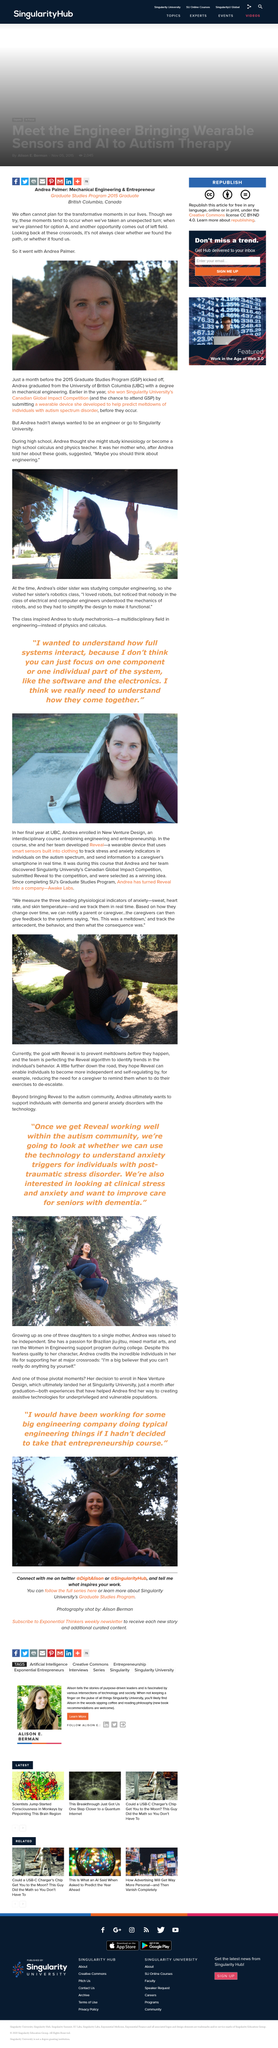Specify some key components in this picture. We, at Reveal, aspire to empower individuals by enabling them to become more independent and self-regulating. Andrea was raised to be independent, and as a result, she is self-reliant and confident in her abilities. The depiction of Andrea is present in the photo. Andrea graduated from the University of British Columbia just a month before the 2015 Graduate Studies Program began. The person who has a passion for Brazilian jiu-jitsu has landed at Singularity University. 